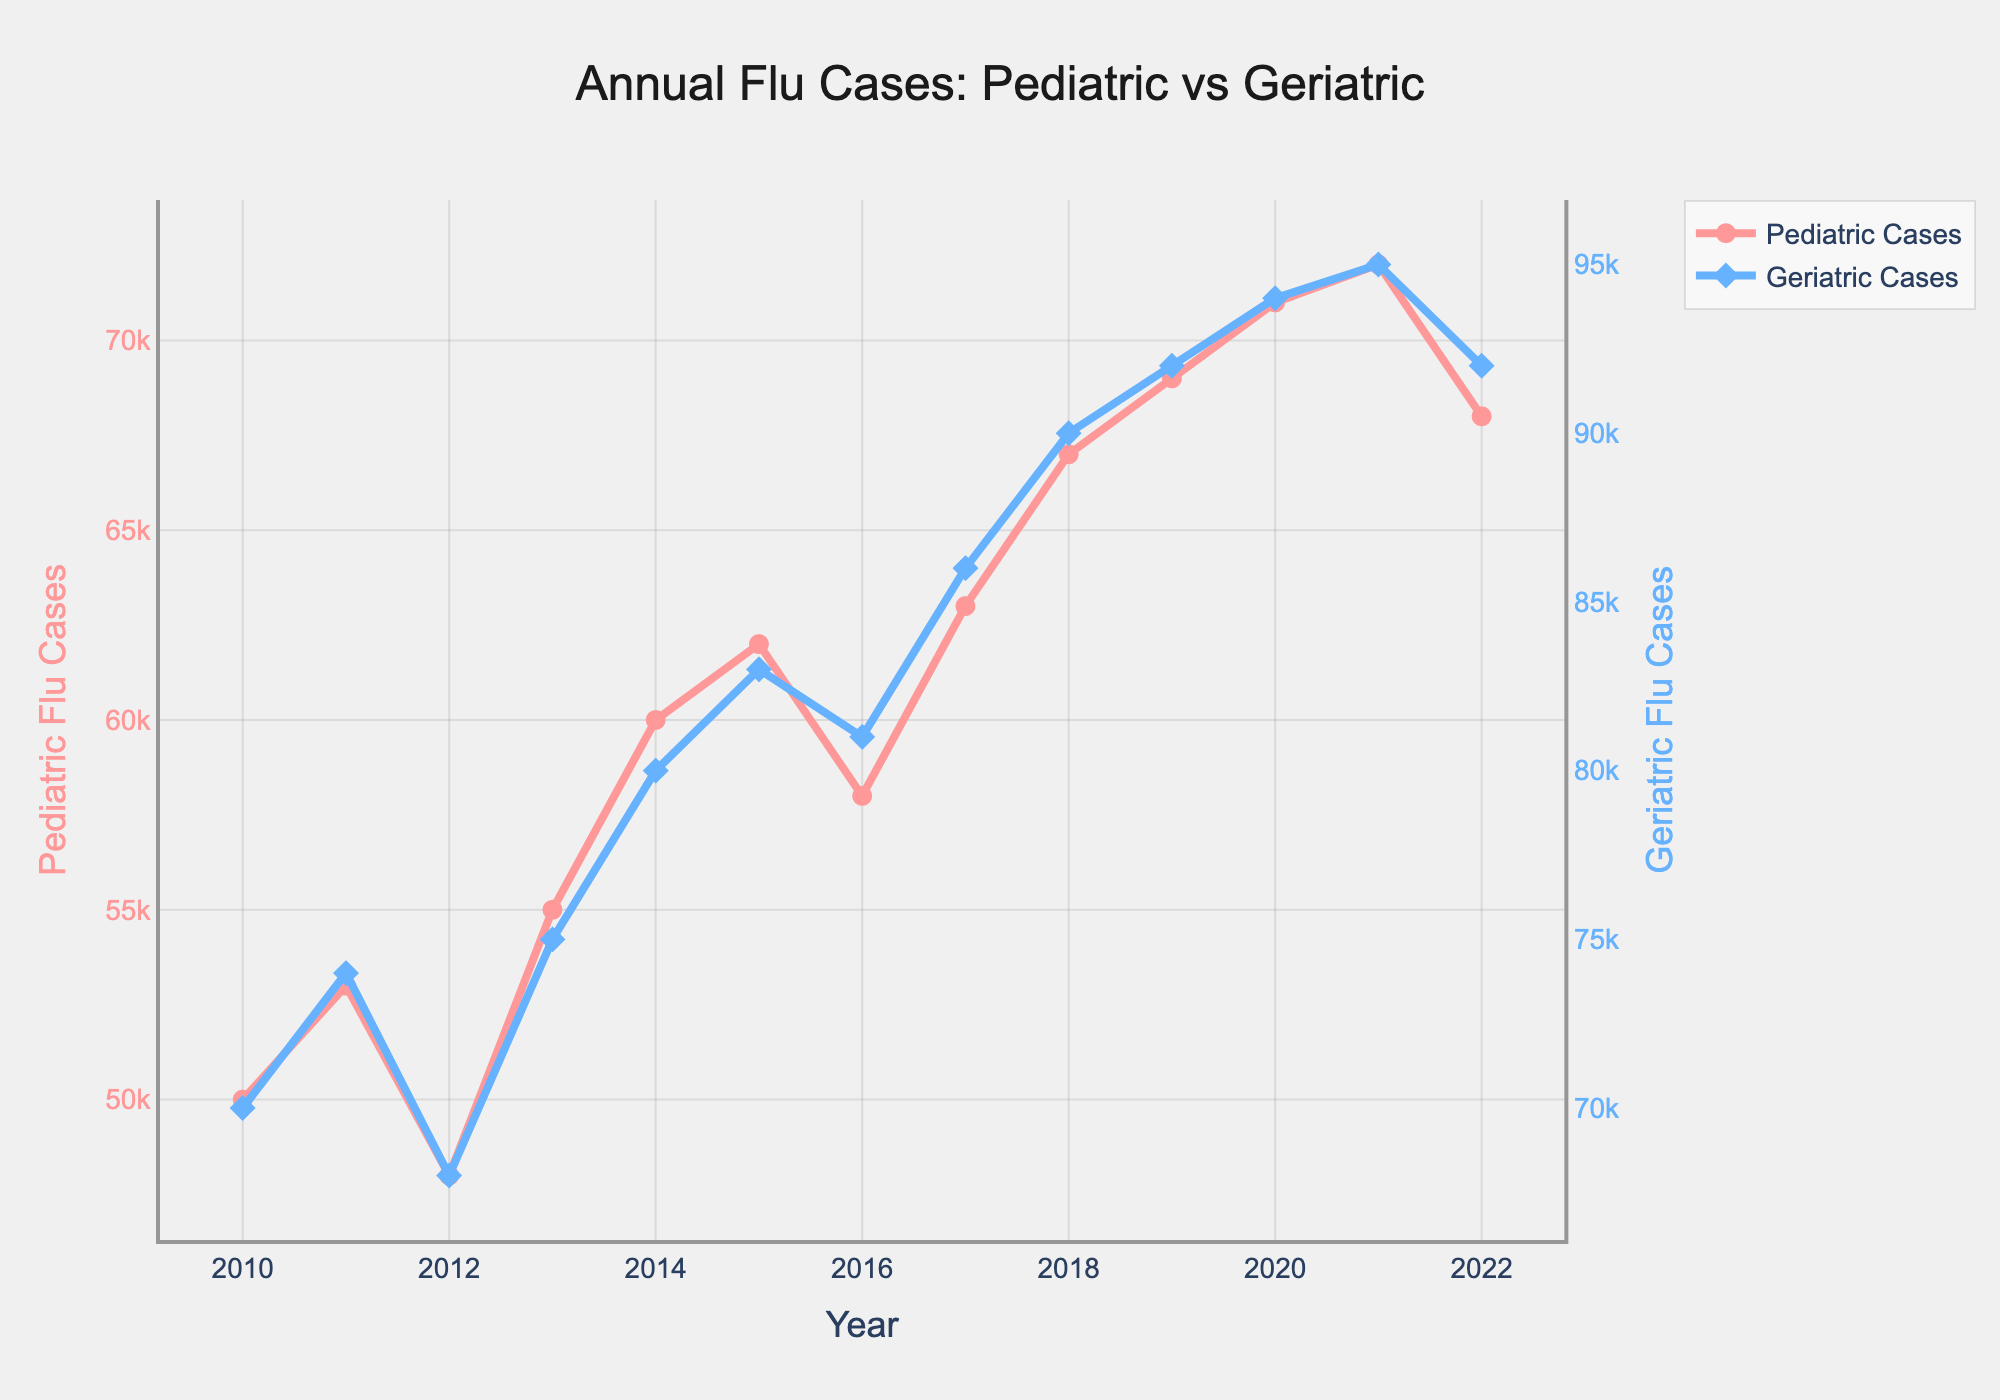What is the title of the plot? The title is usually located at the top of the plot. In this case, it reads "Annual Flu Cases: Pediatric vs Geriatric".
Answer: Annual Flu Cases: Pediatric vs Geriatric What is the trend of Pediatric Flu Cases from 2010 to 2022? The Pediatric Flu Cases generally show an increasing trend from 50,000 cases in 2010 to 72,000 cases in 2021, with a slight drop to 68,000 cases in 2022.
Answer: Increasing overall Which year had the highest number of Geriatric Flu Cases? By inspecting the plot, the highest point on the Geriatric Flu Cases line is in 2021, where it reaches 95,000 cases.
Answer: 2021 How do the Pediatric and Geriatric Flu Cases compare in 2014? In 2014, the Pediatric Flu Cases are 60,000, while Geriatric Flu Cases are 80,000. Comparing these values, Geriatric cases are higher by 20,000.
Answer: Geriatric cases are higher by 20,000 What is the average number of Pediatric Flu Cases between 2010 and 2015? To find the average, sum the Pediatric Flu Cases from 2010 to 2015: (50,000 + 53,000 + 48,000 + 55,000 + 60,000 + 62,000) = 328,000. Then, divide by 6 years: 328,000 / 6 = 54,666.67.
Answer: 54,666.67 Which year saw the largest increase in Pediatric Flu Cases compared to the previous year? By comparing year-to-year changes in the Pediatric line: the largest increase is from 2017 to 2018, with a change from 63,000 to 67,000, an increase of 4,000 cases.
Answer: 2018 Is there any year where Pediatric and Geriatric Flu Cases are equal? By examining the lines, there is no year where the Pediatric and Geriatric Flu Cases intersect or have the same value.
Answer: No What is the combined number of Pediatric and Geriatric Flu Cases in 2020? The Pediatric Flu Cases in 2020 are 71,000, and Geriatric Flu Cases are 94,000. Combined, this is 71,000 + 94,000 = 165,000 cases.
Answer: 165,000 How did the number of Geriatric Flu Cases change from 2019 to 2022? Geriatric Flu Cases increased from 92,000 in 2019 to 95,000 in 2021, then decreased to 92,000 in 2022.
Answer: Increased slightly then decreased Does the plot show any overlapping markers for Pediatric and Geriatric cases? Observing the plot, Pediatric markers are circles and Geriatric markers are diamonds, with no overlapping markers noted.
Answer: No 